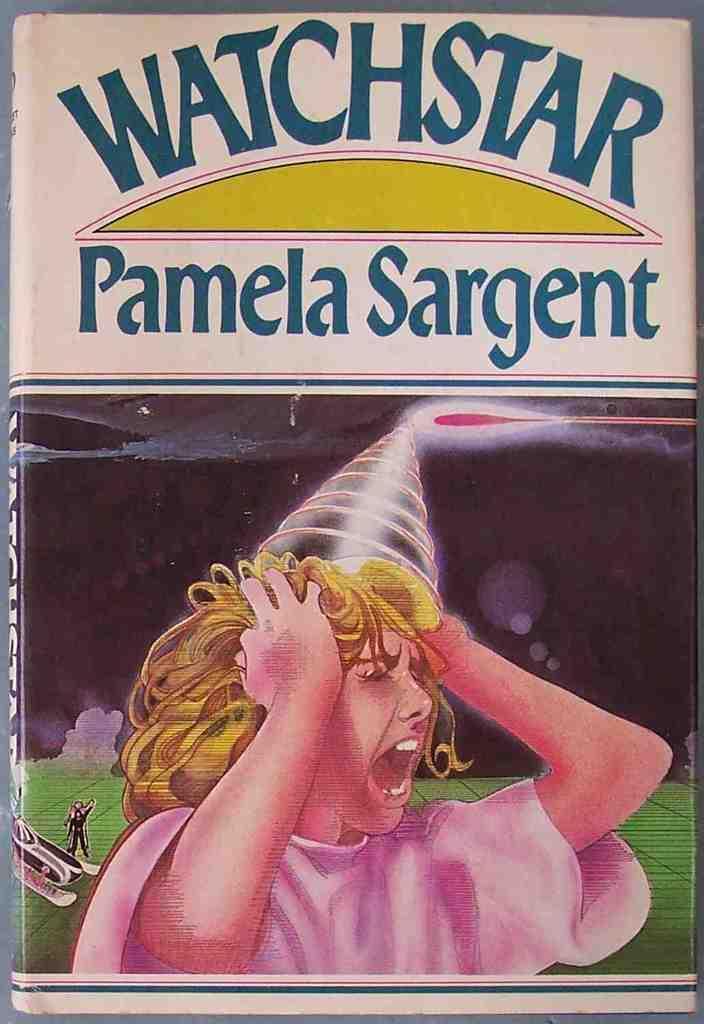Can you describe this image briefly? In this image we can see a book cover with some text and depiction of a girl on it. 